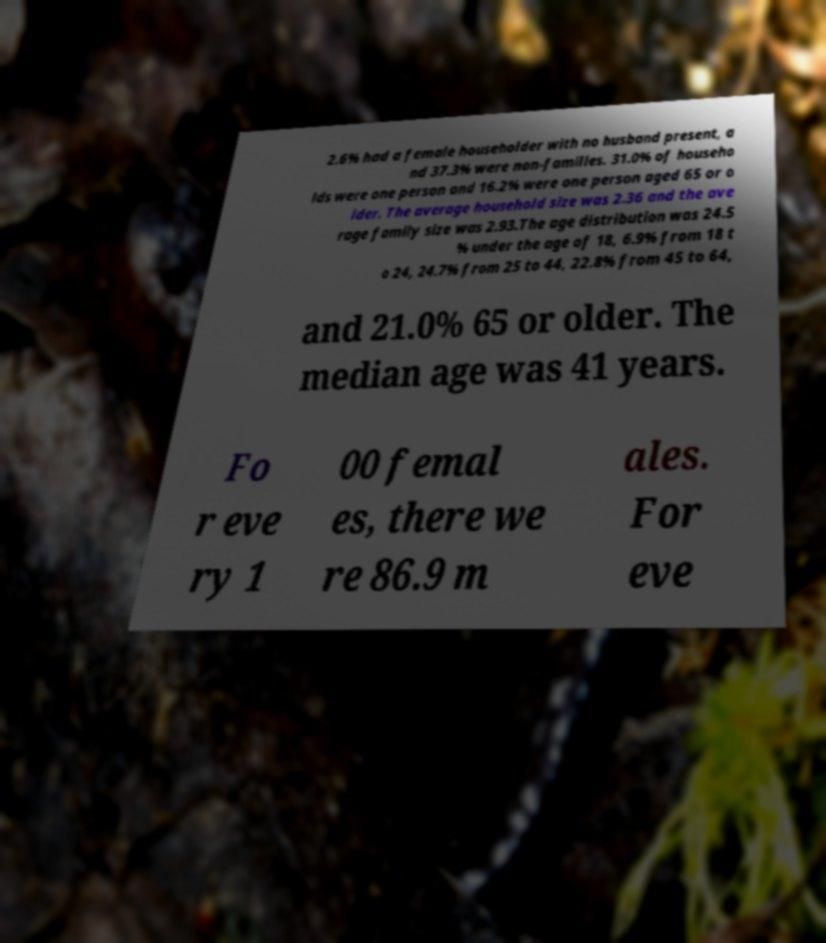Could you extract and type out the text from this image? 2.6% had a female householder with no husband present, a nd 37.3% were non-families. 31.0% of househo lds were one person and 16.2% were one person aged 65 or o lder. The average household size was 2.36 and the ave rage family size was 2.93.The age distribution was 24.5 % under the age of 18, 6.9% from 18 t o 24, 24.7% from 25 to 44, 22.8% from 45 to 64, and 21.0% 65 or older. The median age was 41 years. Fo r eve ry 1 00 femal es, there we re 86.9 m ales. For eve 